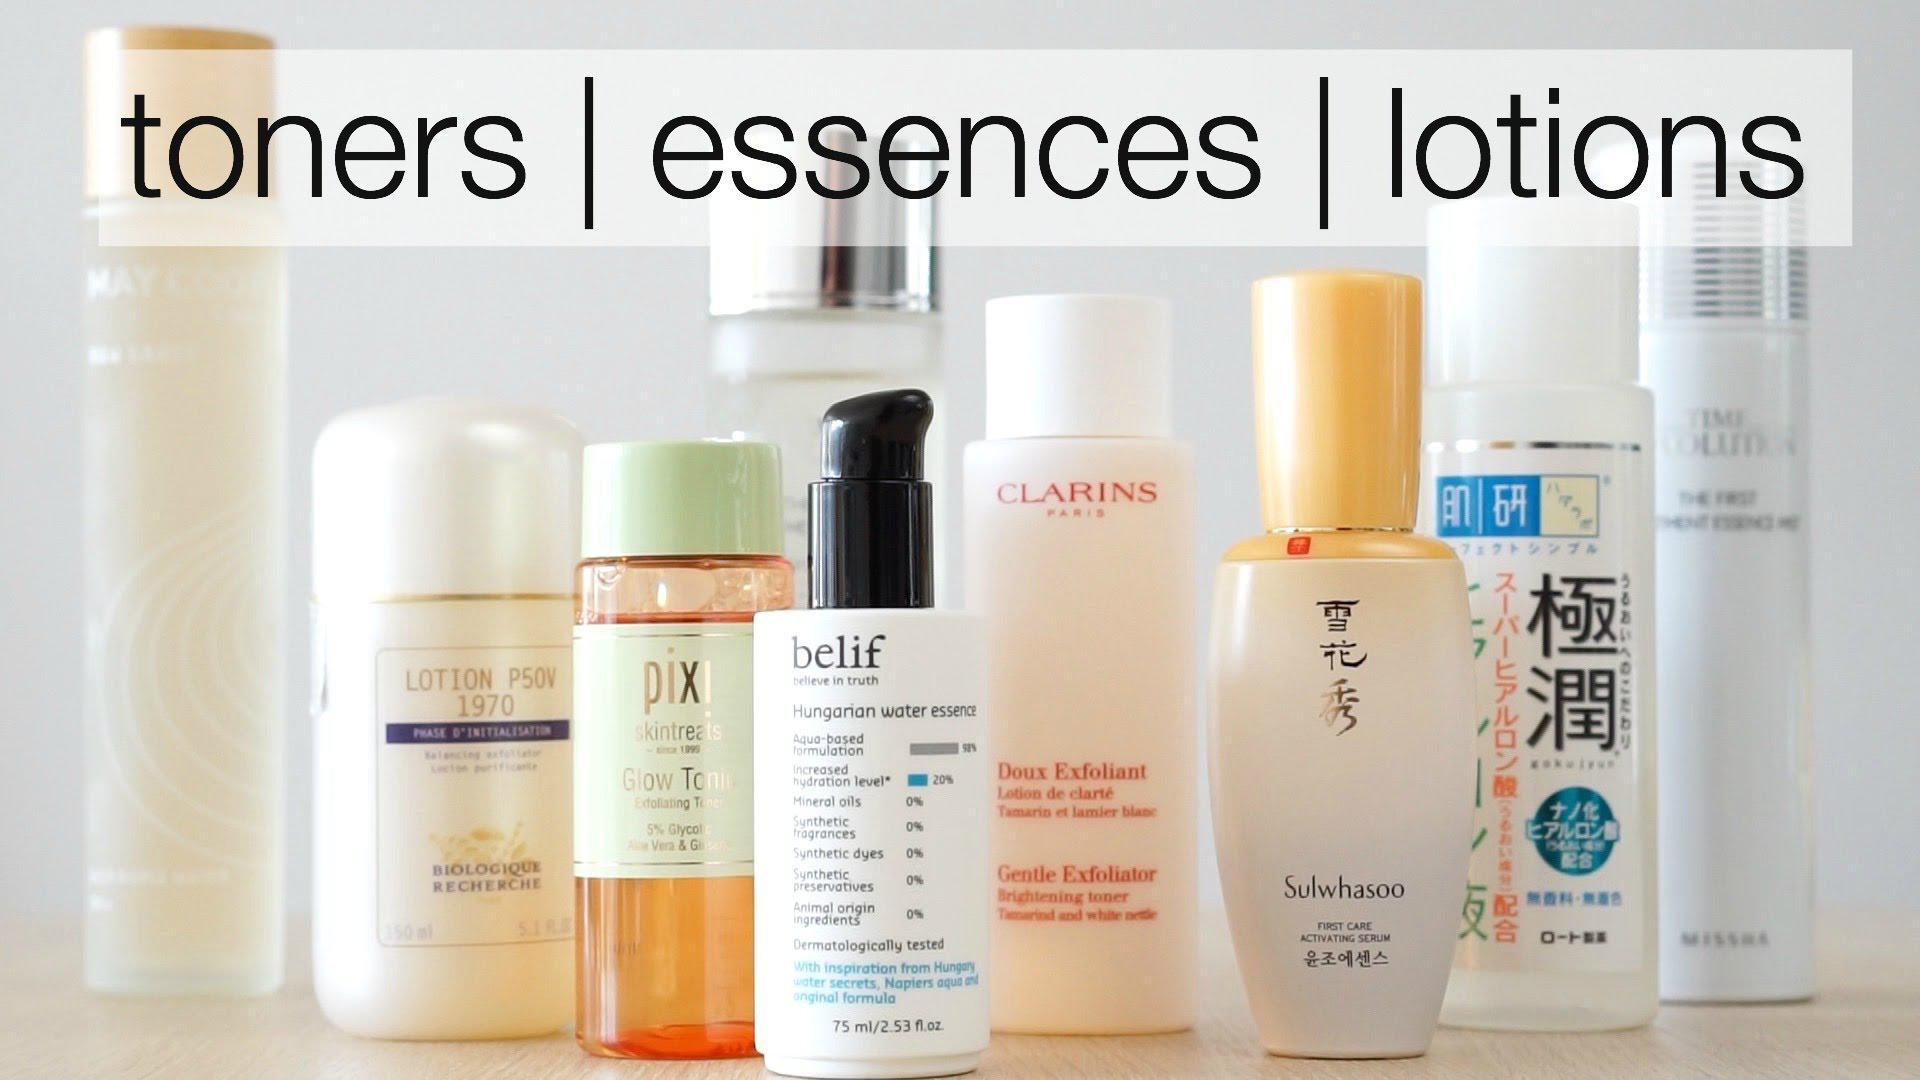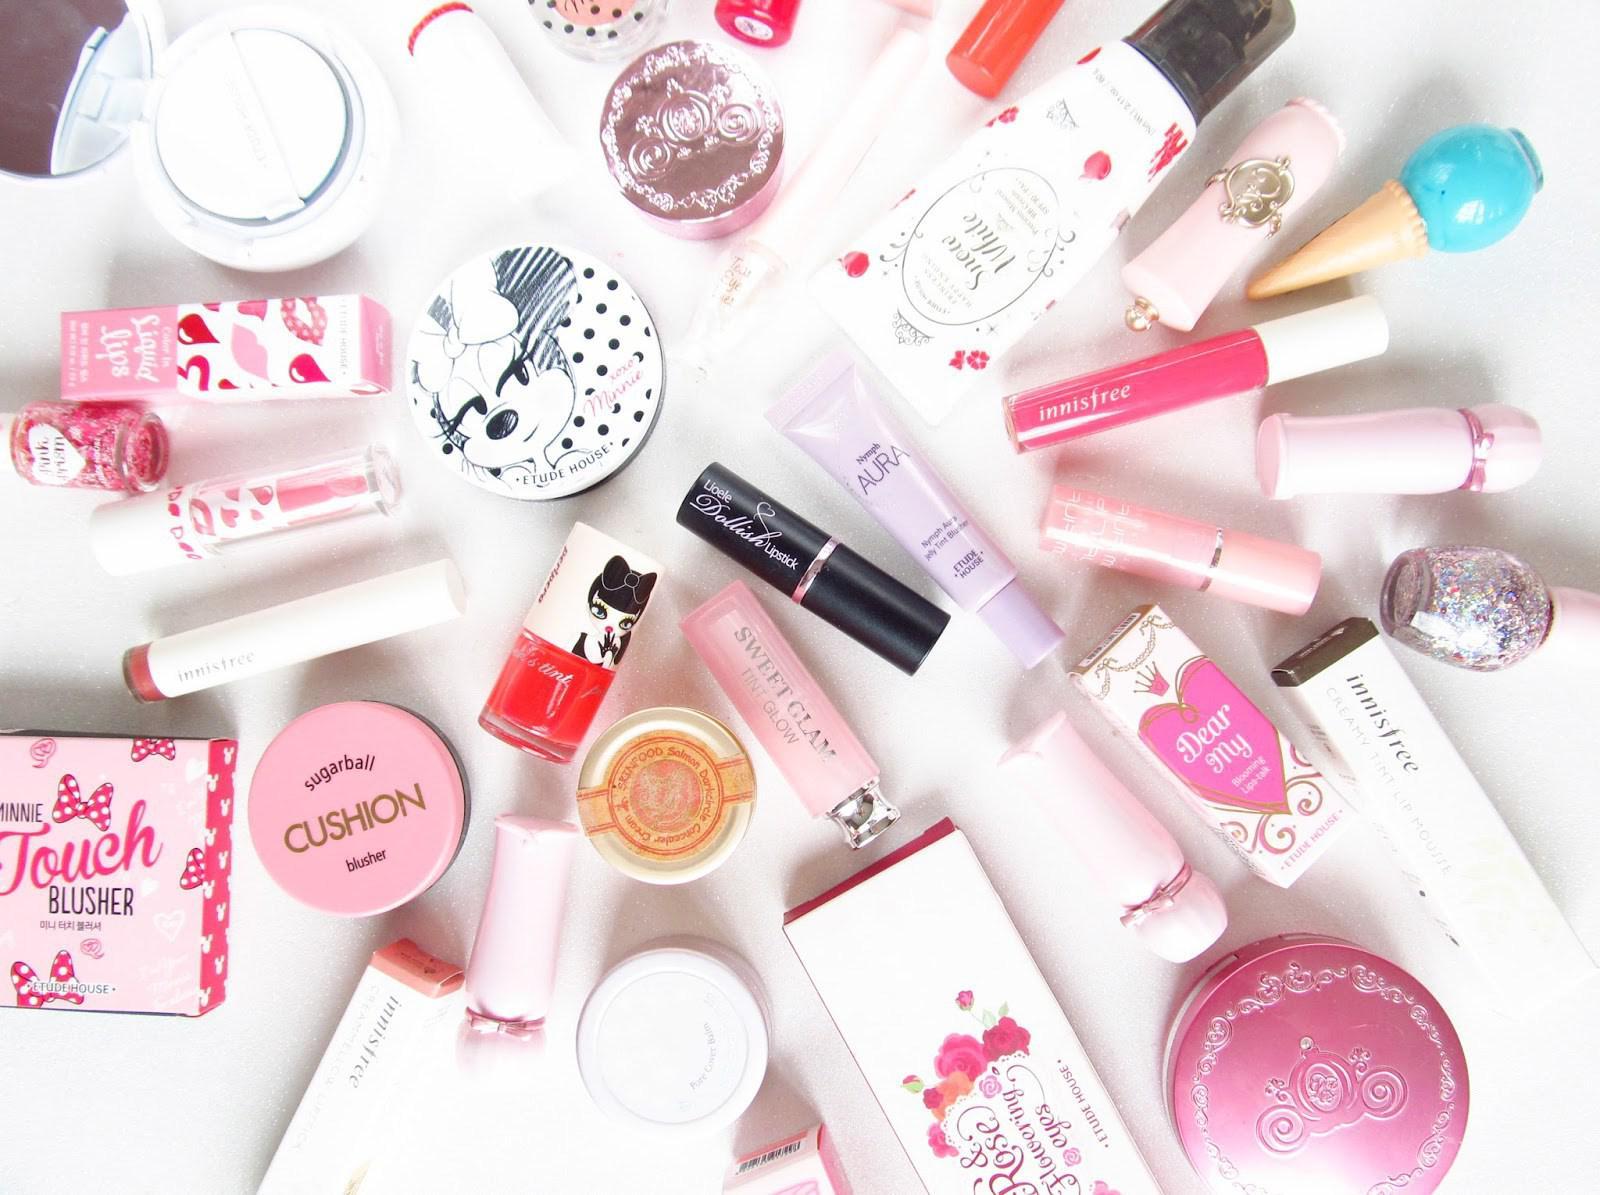The first image is the image on the left, the second image is the image on the right. Analyze the images presented: Is the assertion "IN at least one image there is at least one lipstick lying on it's side and one chapstick in a round container." valid? Answer yes or no. Yes. The first image is the image on the left, the second image is the image on the right. Evaluate the accuracy of this statement regarding the images: "One image shows no more than three items, which are laid flat on a surface, and the other image includes multiple products displayed standing upright.". Is it true? Answer yes or no. No. 